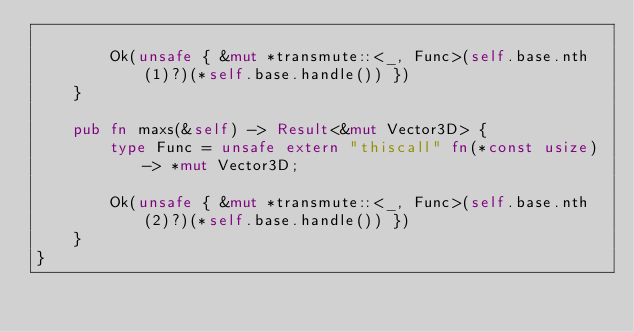Convert code to text. <code><loc_0><loc_0><loc_500><loc_500><_Rust_>
        Ok(unsafe { &mut *transmute::<_, Func>(self.base.nth(1)?)(*self.base.handle()) })
    }

    pub fn maxs(&self) -> Result<&mut Vector3D> {
        type Func = unsafe extern "thiscall" fn(*const usize) -> *mut Vector3D;

        Ok(unsafe { &mut *transmute::<_, Func>(self.base.nth(2)?)(*self.base.handle()) })
    }
}
</code> 